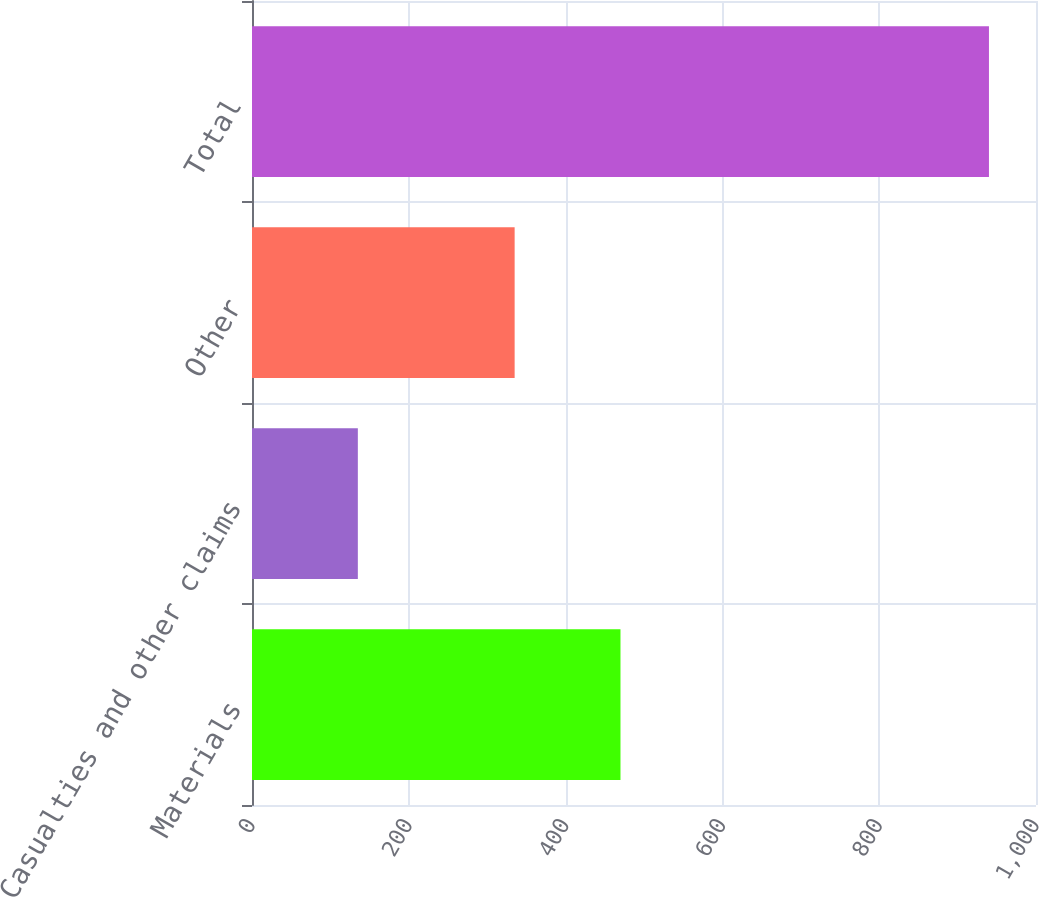<chart> <loc_0><loc_0><loc_500><loc_500><bar_chart><fcel>Materials<fcel>Casualties and other claims<fcel>Other<fcel>Total<nl><fcel>470<fcel>135<fcel>335<fcel>940<nl></chart> 